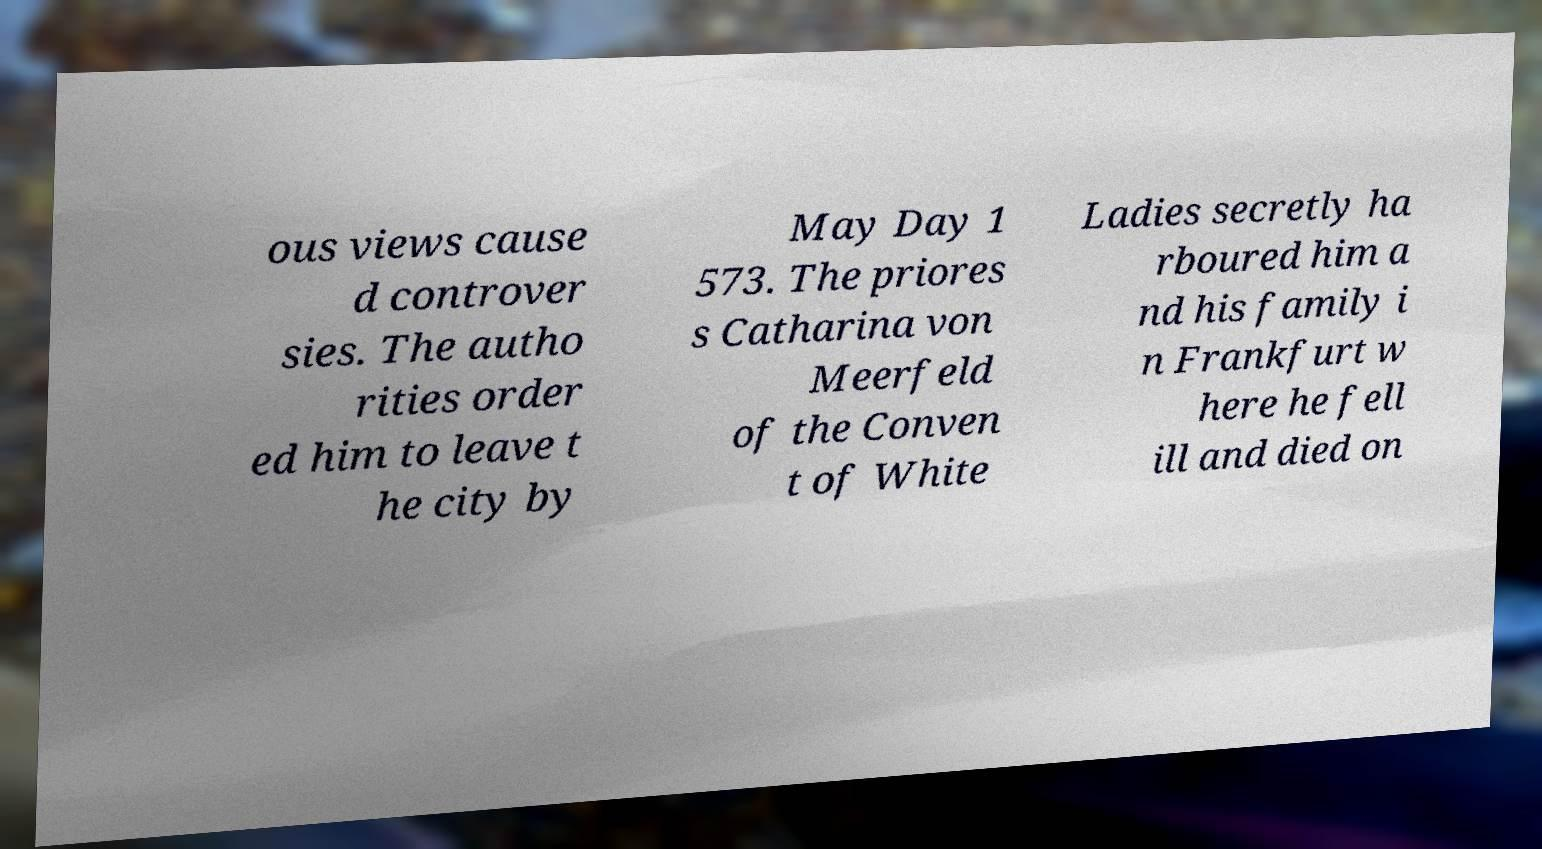Please identify and transcribe the text found in this image. ous views cause d controver sies. The autho rities order ed him to leave t he city by May Day 1 573. The priores s Catharina von Meerfeld of the Conven t of White Ladies secretly ha rboured him a nd his family i n Frankfurt w here he fell ill and died on 